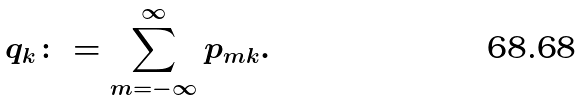<formula> <loc_0><loc_0><loc_500><loc_500>q _ { k } \colon = \sum _ { m = - \infty } ^ { \infty } p _ { m k } .</formula> 